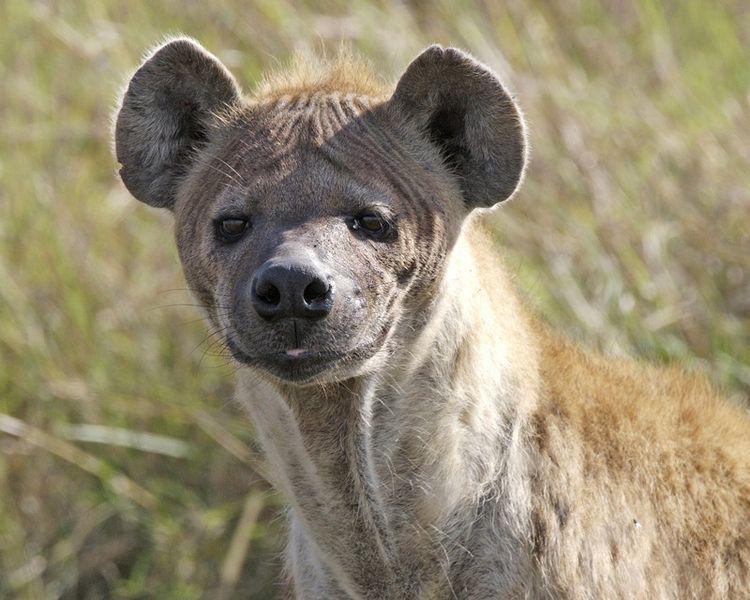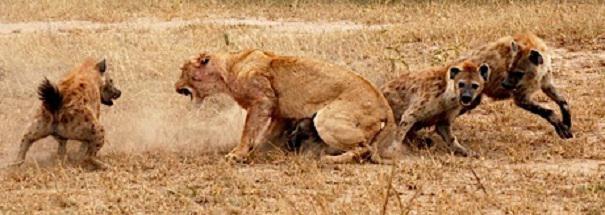The first image is the image on the left, the second image is the image on the right. For the images displayed, is the sentence "One image contains at a least two hyenas." factually correct? Answer yes or no. Yes. 